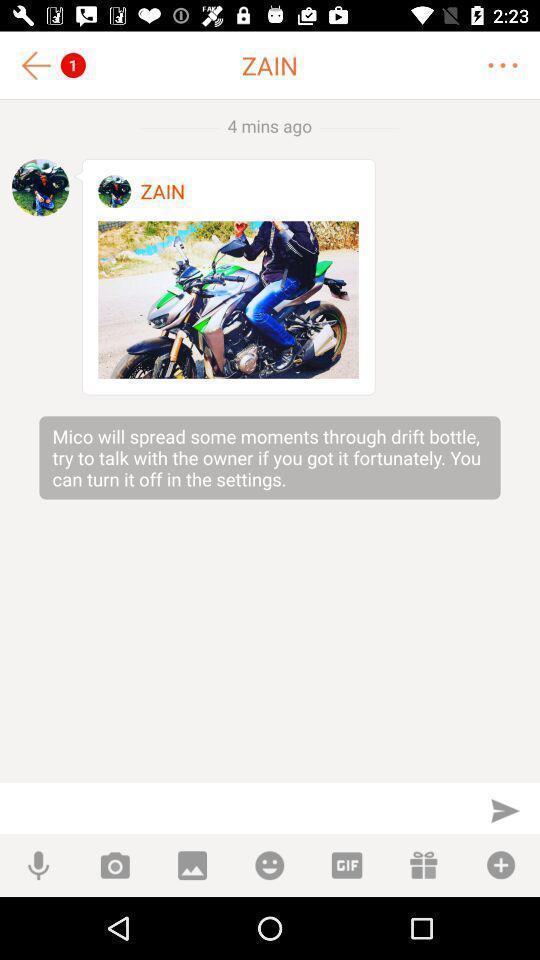Provide a detailed account of this screenshot. Screen shows an image in a chat app. 